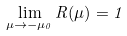Convert formula to latex. <formula><loc_0><loc_0><loc_500><loc_500>\lim _ { \mu \rightarrow - \mu _ { 0 } } R ( \mu ) = 1</formula> 